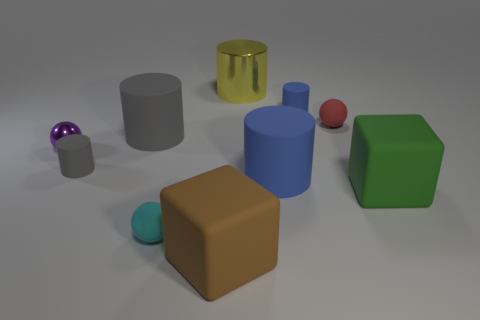Subtract all small rubber cylinders. How many cylinders are left? 3 Subtract all blocks. How many objects are left? 8 Subtract all yellow spheres. How many green cubes are left? 1 Subtract all tiny cylinders. Subtract all purple objects. How many objects are left? 7 Add 8 gray rubber cylinders. How many gray rubber cylinders are left? 10 Add 7 large green cubes. How many large green cubes exist? 8 Subtract all red balls. How many balls are left? 2 Subtract 0 purple blocks. How many objects are left? 10 Subtract 5 cylinders. How many cylinders are left? 0 Subtract all green cylinders. Subtract all green blocks. How many cylinders are left? 5 